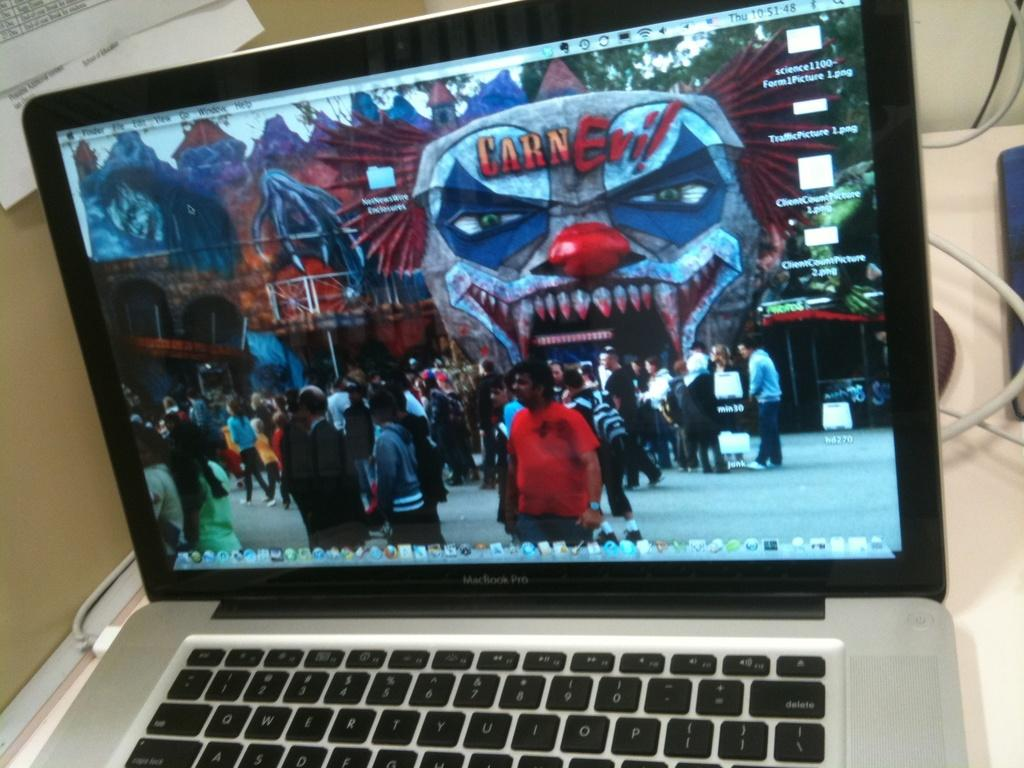Provide a one-sentence caption for the provided image. A laptop displays an image from a scary event called Carn-Evil. 